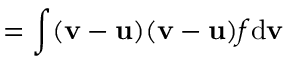<formula> <loc_0><loc_0><loc_500><loc_500>{ \mathbf \Pi } = \int ( { \mathbf v } - { \mathbf u } ) ( { \mathbf v } - { \mathbf u } ) f d { \mathbf v }</formula> 